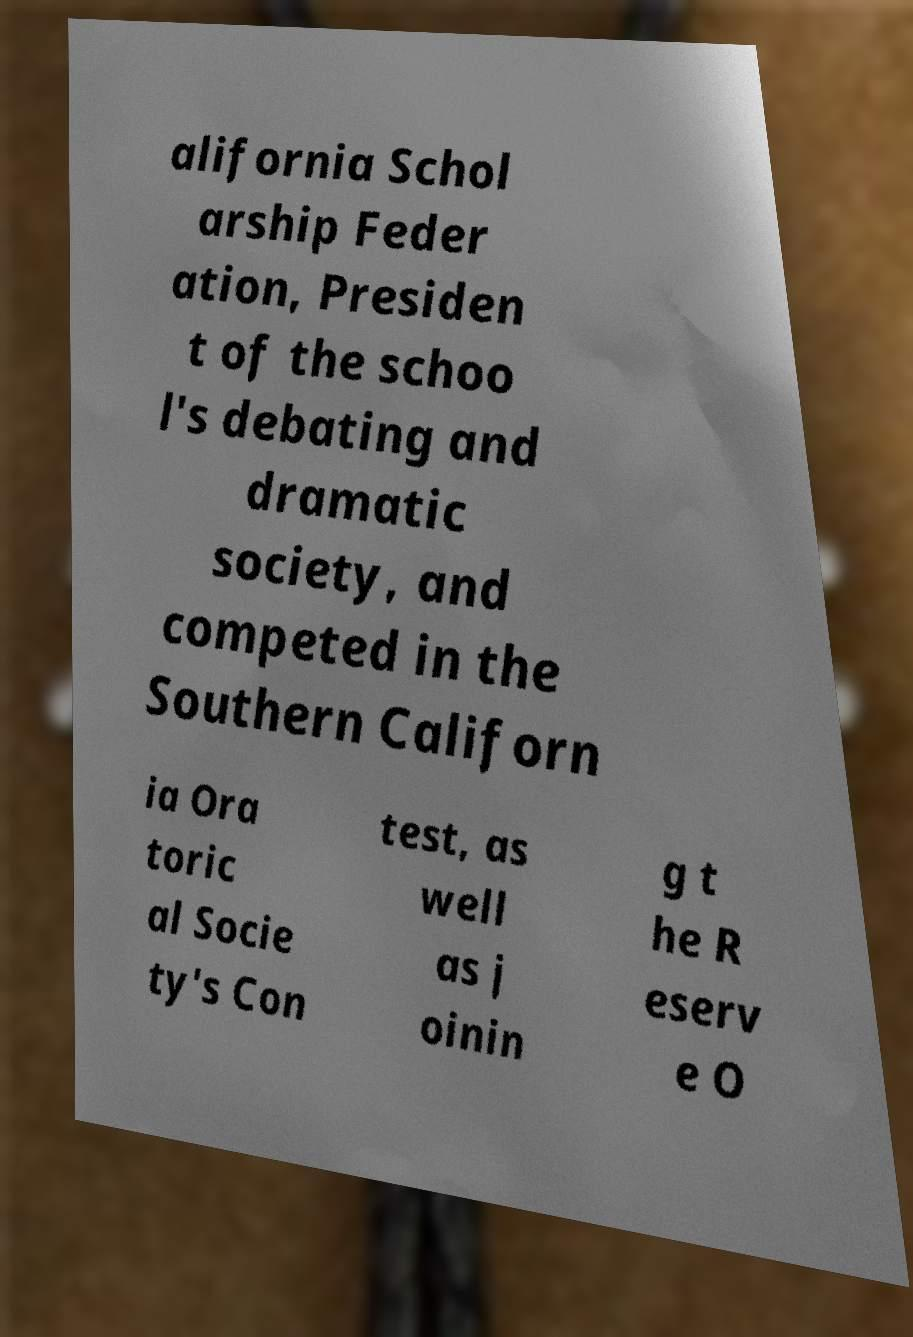Please identify and transcribe the text found in this image. alifornia Schol arship Feder ation, Presiden t of the schoo l's debating and dramatic society, and competed in the Southern Californ ia Ora toric al Socie ty's Con test, as well as j oinin g t he R eserv e O 